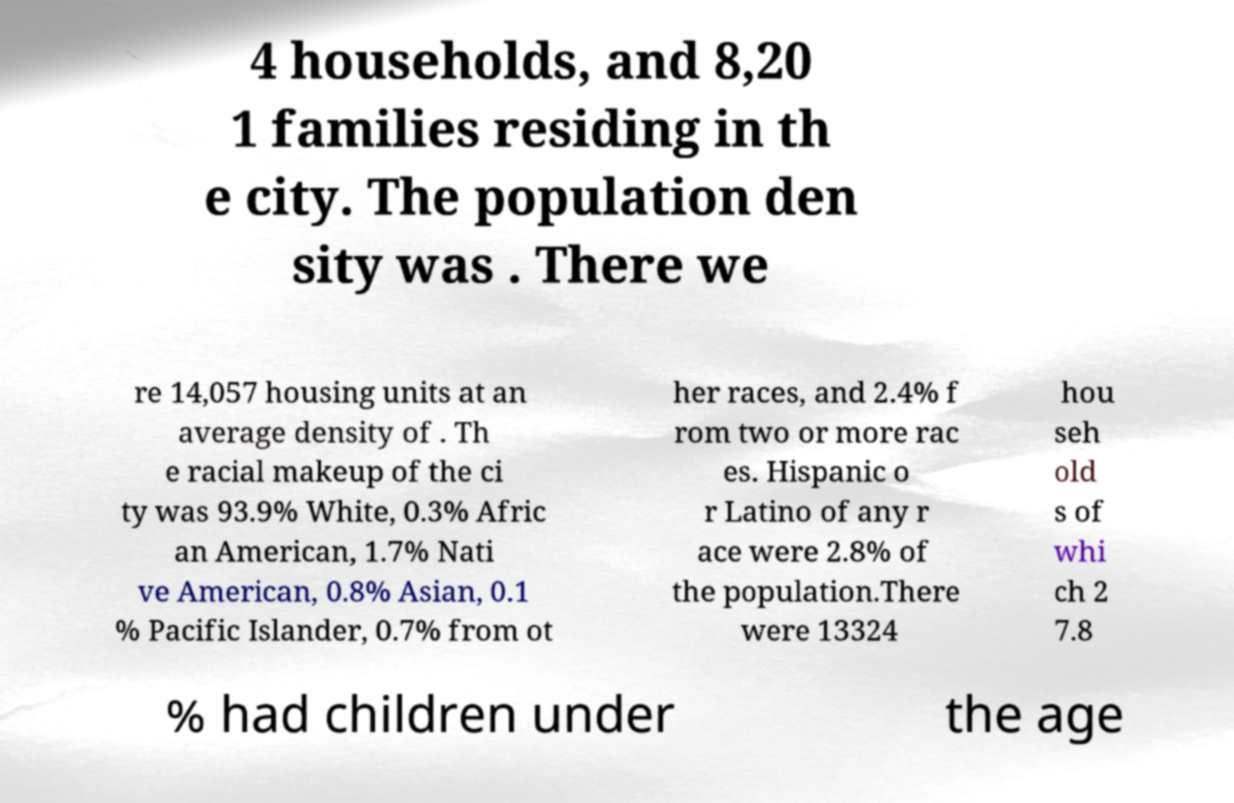Could you assist in decoding the text presented in this image and type it out clearly? 4 households, and 8,20 1 families residing in th e city. The population den sity was . There we re 14,057 housing units at an average density of . Th e racial makeup of the ci ty was 93.9% White, 0.3% Afric an American, 1.7% Nati ve American, 0.8% Asian, 0.1 % Pacific Islander, 0.7% from ot her races, and 2.4% f rom two or more rac es. Hispanic o r Latino of any r ace were 2.8% of the population.There were 13324 hou seh old s of whi ch 2 7.8 % had children under the age 